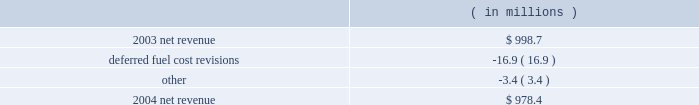Entergy arkansas , inc .
Management's financial discussion and analysis results of operations net income 2004 compared to 2003 net income increased $ 16.2 million due to lower other operation and maintenance expenses , a lower effective income tax rate for 2004 compared to 2003 , and lower interest charges .
The increase was partially offset by lower net revenue .
2003 compared to 2002 net income decreased $ 9.6 million due to lower net revenue , higher depreciation and amortization expenses , and a higher effective income tax rate for 2003 compared to 2002 .
The decrease was substantially offset by lower other operation and maintenance expenses , higher other income , and lower interest charges .
Net revenue 2004 compared to 2003 net revenue , which is entergy arkansas' measure of gross margin , consists of operating revenues net of : 1 ) fuel , fuel-related , and purchased power expenses and 2 ) other regulatory credits .
Following is an analysis of the change in net revenue comparing 2004 to 2003. .
Deferred fuel cost revisions includes the difference between the estimated deferred fuel expense and the actual calculation of recoverable fuel expense , which occurs on an annual basis .
Deferred fuel cost revisions decreased net revenue due to a revised estimate of fuel costs filed for recovery at entergy arkansas in the march 2004 energy cost recovery rider , which reduced net revenue by $ 11.5 million .
The remainder of the variance is due to the 2002 energy cost recovery true-up , made in the first quarter of 2003 , which increased net revenue in 2003 .
Gross operating revenues , fuel and purchased power expenses , and other regulatory credits gross operating revenues increased primarily due to : 2022 an increase of $ 20.7 million in fuel cost recovery revenues due to an increase in the energy cost recovery rider effective april 2004 ( fuel cost recovery revenues are discussed in note 2 to the domestic utility companies and system energy financial statements ) ; 2022 an increase of $ 15.5 million in grand gulf revenues due to an increase in the grand gulf rider effective january 2004 ; 2022 an increase of $ 13.9 million in gross wholesale revenue primarily due to increased sales to affiliated systems ; 2022 an increase of $ 9.5 million due to volume/weather primarily resulting from increased usage during the unbilled sales period , partially offset by the effect of milder weather on billed sales in 2004. .
What are the deferred fuel cost revisions as a percentage of the decrease in net revenue from 2003 to 2004? 
Computations: (11.5 / (998.7 - 978.4))
Answer: 0.5665. 